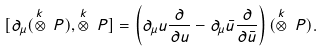Convert formula to latex. <formula><loc_0><loc_0><loc_500><loc_500>[ \partial _ { \mu } ( \stackrel { k } { \otimes } \, P ) , \stackrel { k } { \otimes } \, P ] = \left ( \partial _ { \mu } u \frac { \partial } { \partial u } - \partial _ { \mu } \bar { u } \frac { \partial } { \partial \bar { u } } \right ) ( \stackrel { k } { \otimes } \, P ) .</formula> 